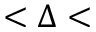Convert formula to latex. <formula><loc_0><loc_0><loc_500><loc_500>< \Delta <</formula> 